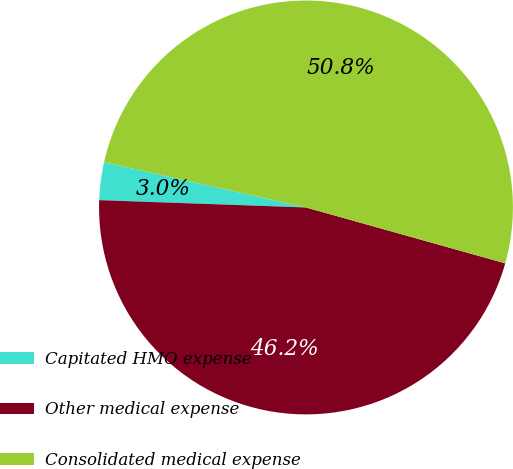Convert chart to OTSL. <chart><loc_0><loc_0><loc_500><loc_500><pie_chart><fcel>Capitated HMO expense<fcel>Other medical expense<fcel>Consolidated medical expense<nl><fcel>2.95%<fcel>46.21%<fcel>50.84%<nl></chart> 